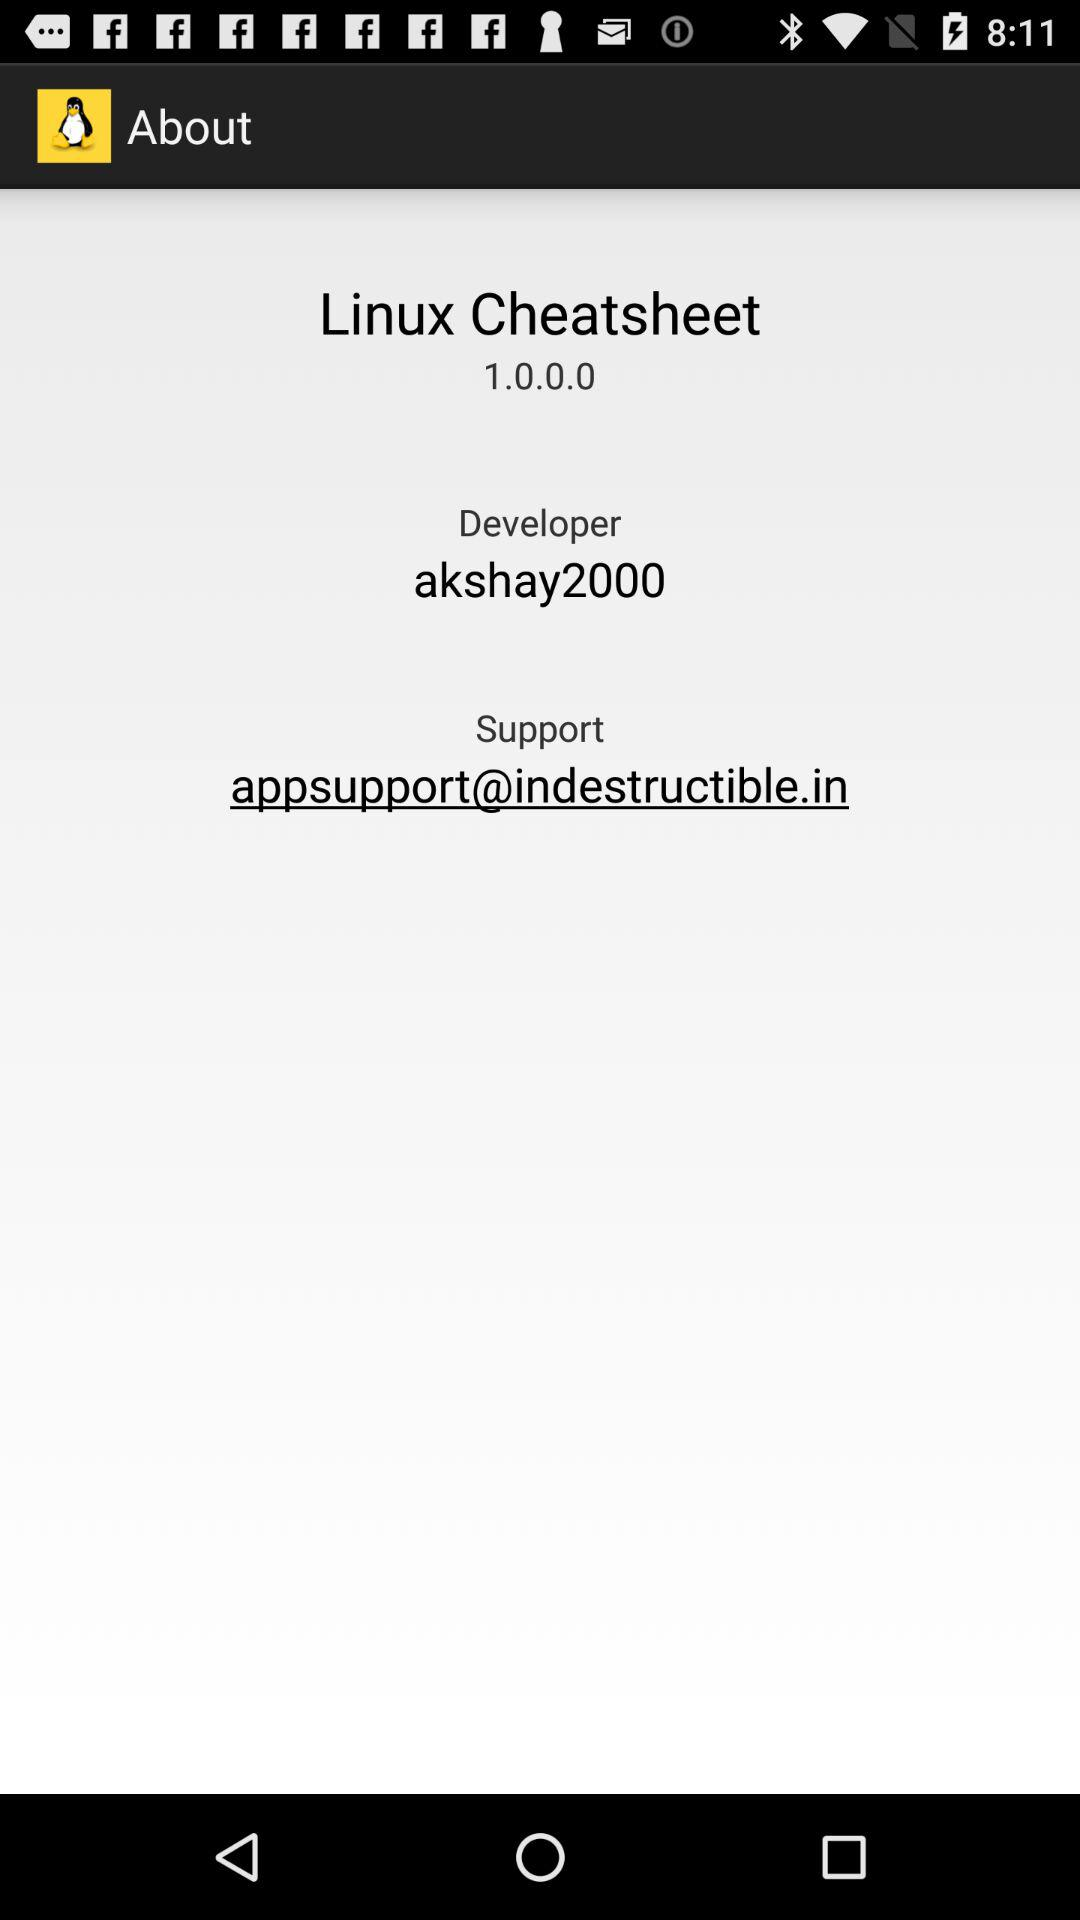What is the name of the developer? The name of the developer is "akshay2000". 